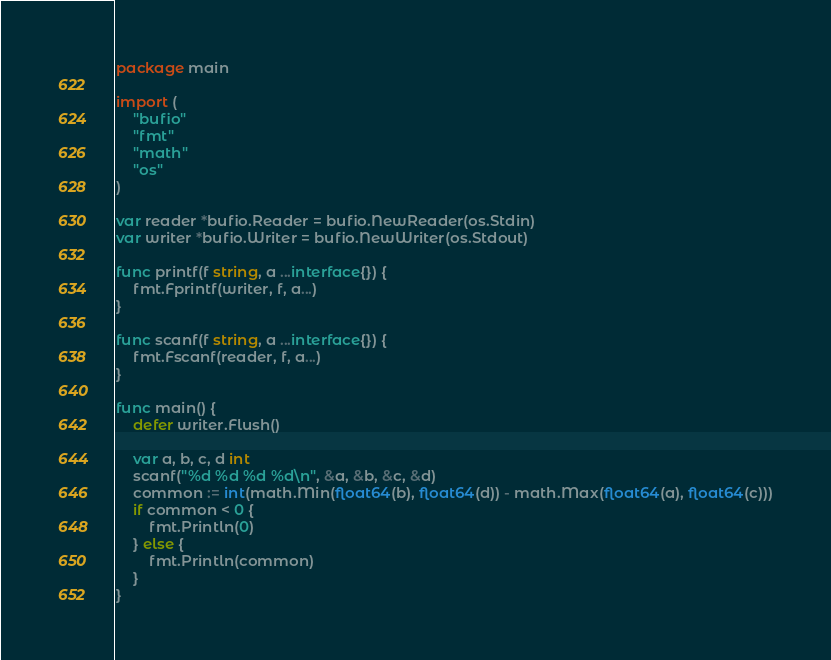<code> <loc_0><loc_0><loc_500><loc_500><_Go_>package main

import (
	"bufio"
	"fmt"
	"math"
	"os"
)

var reader *bufio.Reader = bufio.NewReader(os.Stdin)
var writer *bufio.Writer = bufio.NewWriter(os.Stdout)

func printf(f string, a ...interface{}) {
	fmt.Fprintf(writer, f, a...)
}

func scanf(f string, a ...interface{}) {
	fmt.Fscanf(reader, f, a...)
}

func main() {
	defer writer.Flush()

	var a, b, c, d int
	scanf("%d %d %d %d\n", &a, &b, &c, &d)
	common := int(math.Min(float64(b), float64(d)) - math.Max(float64(a), float64(c)))
	if common < 0 {
		fmt.Println(0)
	} else {
		fmt.Println(common)
	}
}
</code> 